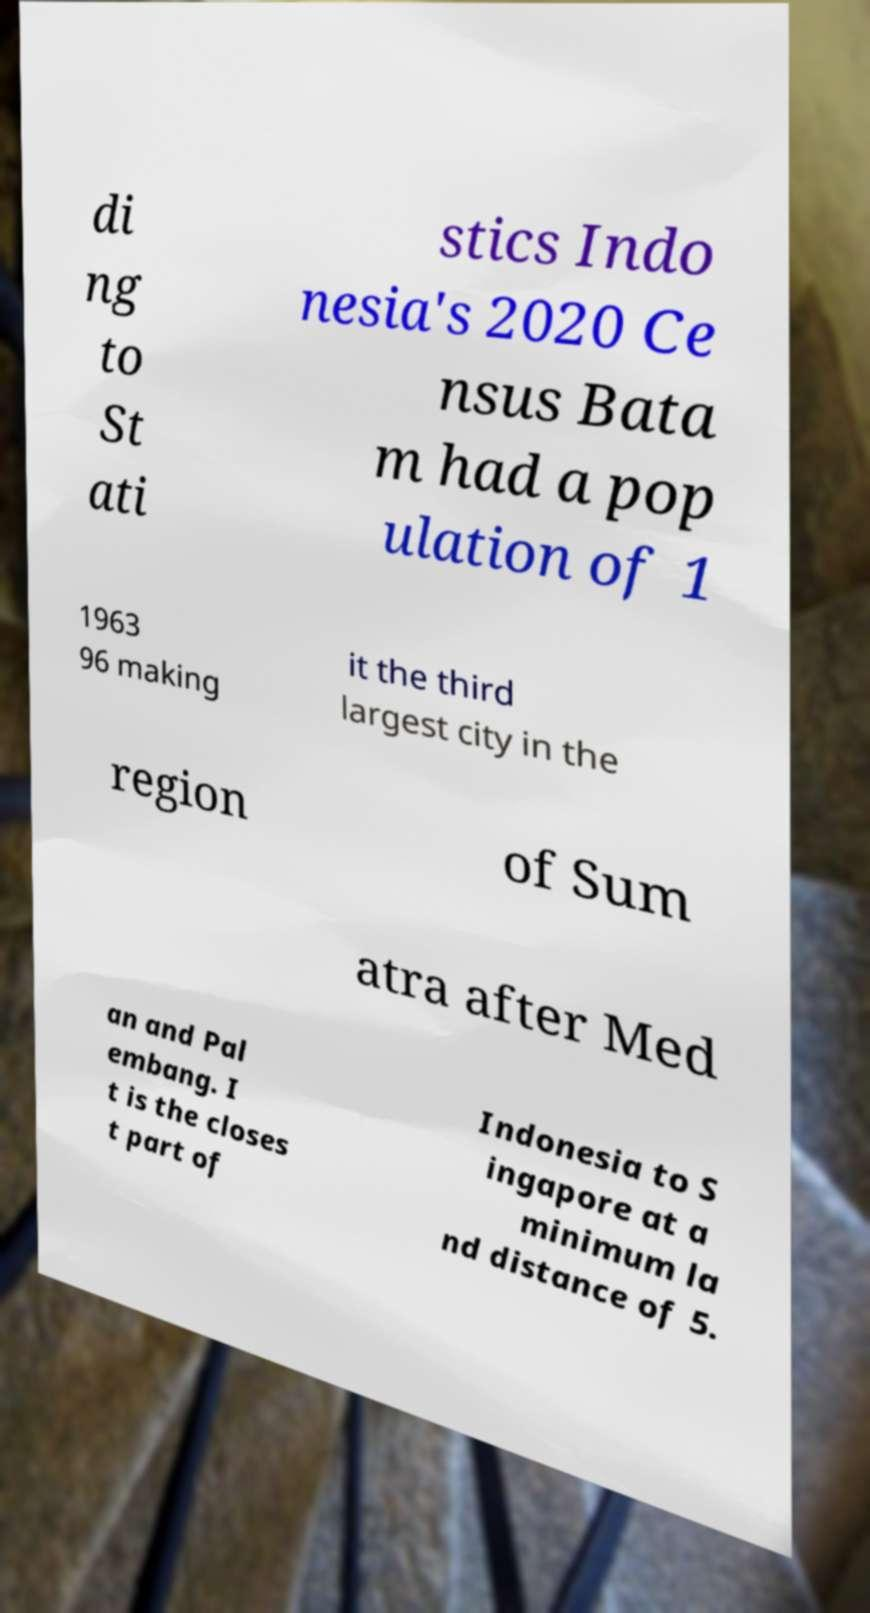Could you extract and type out the text from this image? di ng to St ati stics Indo nesia's 2020 Ce nsus Bata m had a pop ulation of 1 1963 96 making it the third largest city in the region of Sum atra after Med an and Pal embang. I t is the closes t part of Indonesia to S ingapore at a minimum la nd distance of 5. 